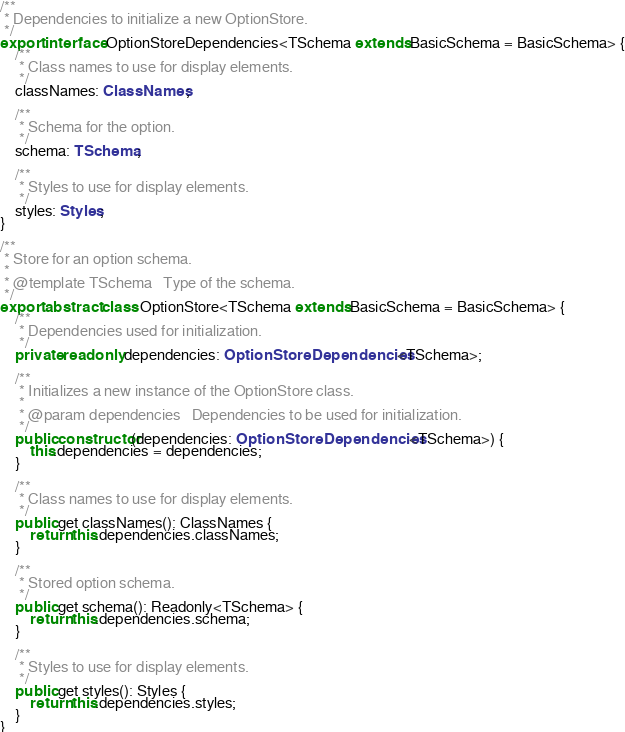Convert code to text. <code><loc_0><loc_0><loc_500><loc_500><_TypeScript_>/**
 * Dependencies to initialize a new OptionStore.
 */
export interface OptionStoreDependencies<TSchema extends BasicSchema = BasicSchema> {
    /**
     * Class names to use for display elements.
     */
    classNames: ClassNames;

    /**
     * Schema for the option.
     */
    schema: TSchema;

    /**
     * Styles to use for display elements.
     */
    styles: Styles;
}

/**
 * Store for an option schema.
 *
 * @template TSchema   Type of the schema.
 */
export abstract class OptionStore<TSchema extends BasicSchema = BasicSchema> {
    /**
     * Dependencies used for initialization.
     */
    private readonly dependencies: OptionStoreDependencies<TSchema>;

    /**
     * Initializes a new instance of the OptionStore class.
     *
     * @param dependencies   Dependencies to be used for initialization.
     */
    public constructor(dependencies: OptionStoreDependencies<TSchema>) {
        this.dependencies = dependencies;
    }

    /**
     * Class names to use for display elements.
     */
    public get classNames(): ClassNames {
        return this.dependencies.classNames;
    }

    /**
     * Stored option schema.
     */
    public get schema(): Readonly<TSchema> {
        return this.dependencies.schema;
    }

    /**
     * Styles to use for display elements.
     */
    public get styles(): Styles {
        return this.dependencies.styles;
    }
}
</code> 